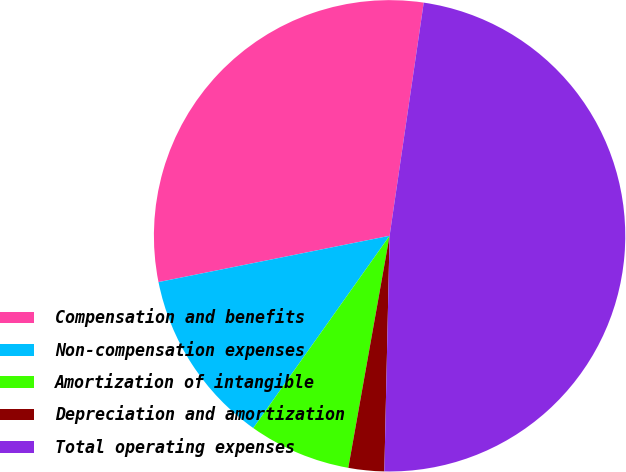Convert chart. <chart><loc_0><loc_0><loc_500><loc_500><pie_chart><fcel>Compensation and benefits<fcel>Non-compensation expenses<fcel>Amortization of intangible<fcel>Depreciation and amortization<fcel>Total operating expenses<nl><fcel>30.46%<fcel>12.04%<fcel>7.01%<fcel>2.45%<fcel>48.04%<nl></chart> 